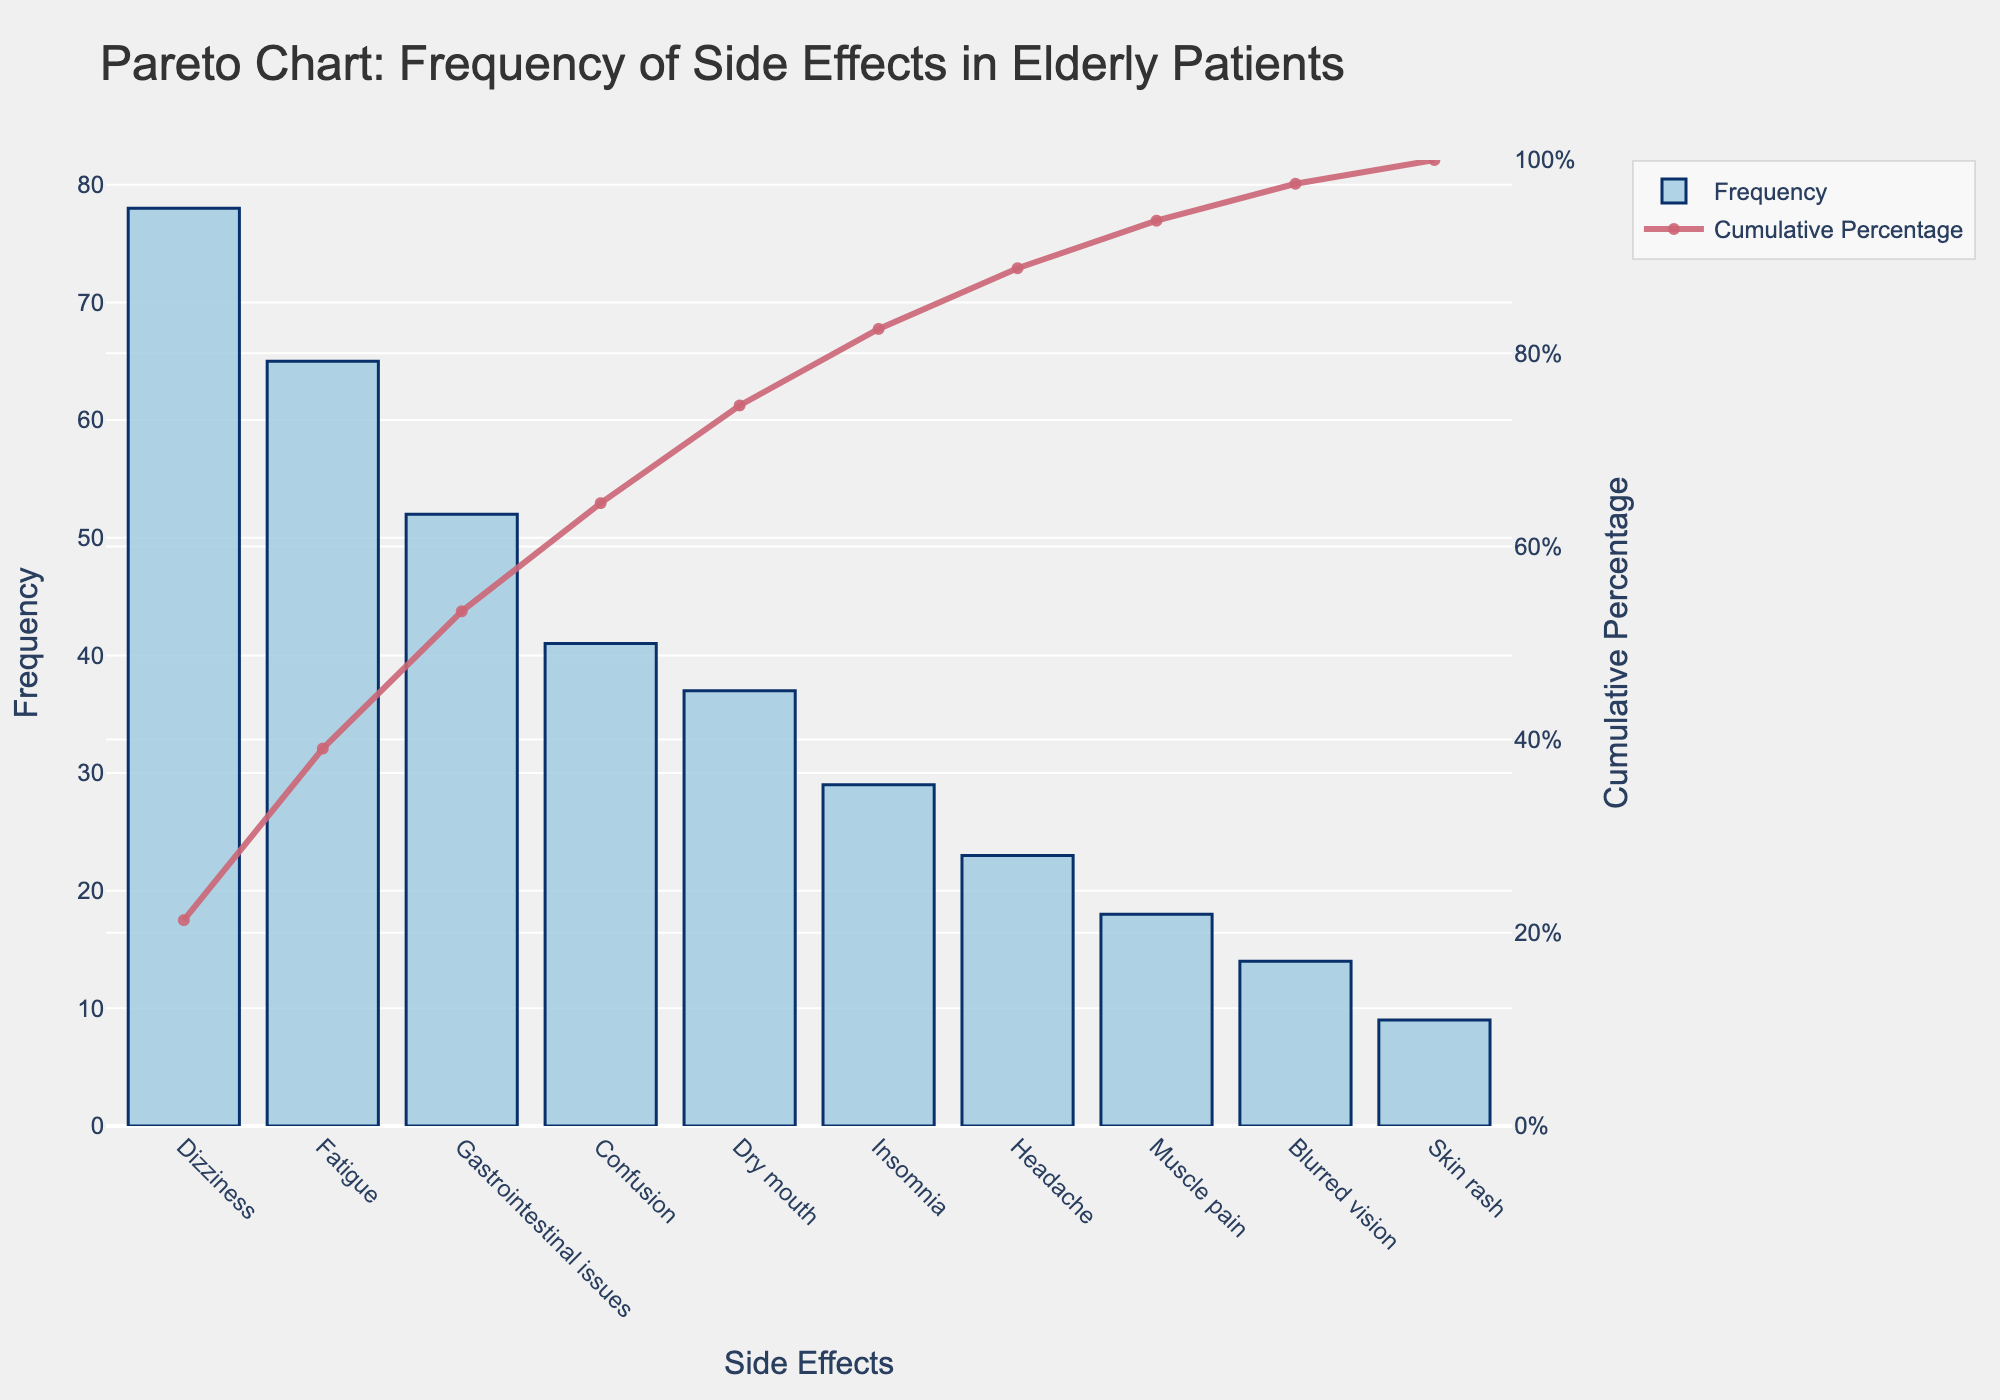What is the most frequently reported side effect? The most frequently reported side effect is the one with the highest bar in the chart. The bar labeled "Dizziness" has the highest frequency.
Answer: Dizziness How many side effects have a frequency above 20? To find the side effects with a frequency above 20, count the bars that have a height greater than 20 on the y-axis. These are Dizziness, Fatigue, Gastrointestinal issues, Confusion, Dry mouth, Insomnia, and Headache.
Answer: 7 Which side effect has the lowest frequency? The side effect with the lowest frequency corresponds to the shortest bar on the chart. The bar labeled "Skin rash" is the shortest, indicating it has the lowest frequency.
Answer: Skin rash What percentage of the total side effects does dizziness account for? Find the frequency of dizziness (78) and divide it by the total sum of frequencies, then multiply by 100 to get the percentage. \( \frac{78}{366} \times 100 \approx 21.31\% \)
Answer: 21.31% How many side effects account for about 80% of the cumulative percentage? Look at the cumulative percentage line where it reaches close to 80%. This occurs around the sixth or seventh side effect on the x-axis. Therefore, approximately 6 or 7 side effects account for 80% of the cumulative percentage.
Answer: 6 or 7 What is the cumulative percentage after the third most frequent side effect? Find the cumulative percentage value corresponding to the third side effect on the x-axis. The third side effect is Gastrointestinal issues, which has a cumulative percentage of around 53%.
Answer: 53% How does the frequency of Muscle pain compare to Headache? Compare the heights of the bars for Muscle pain and Headache. Muscle pain has a frequency of 18, while Headache has a frequency of 23. Therefore, Muscle pain has a lower frequency than Headache.
Answer: Muscle pain < Headache If only the top three side effects are considered, what is their combined frequency? Find the frequency values for the top three side effects: Dizziness (78), Fatigue (65), and Gastrointestinal issues (52), and then add them together: \( 78 + 65 + 52 = 195 \).
Answer: 195 What is the cumulative frequency after Dry mouth? Sum the frequencies up to and including Dry mouth: 78 (Dizziness) + 65 (Fatigue) + 52 (Gastrointestinal issues) + 41 (Confusion) + 37 (Dry mouth) = 273.
Answer: 273 